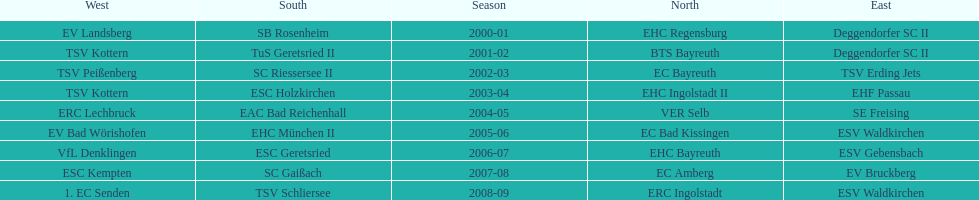Starting with the 2007 - 08 season, does ecs kempten appear in any of the previous years? No. 